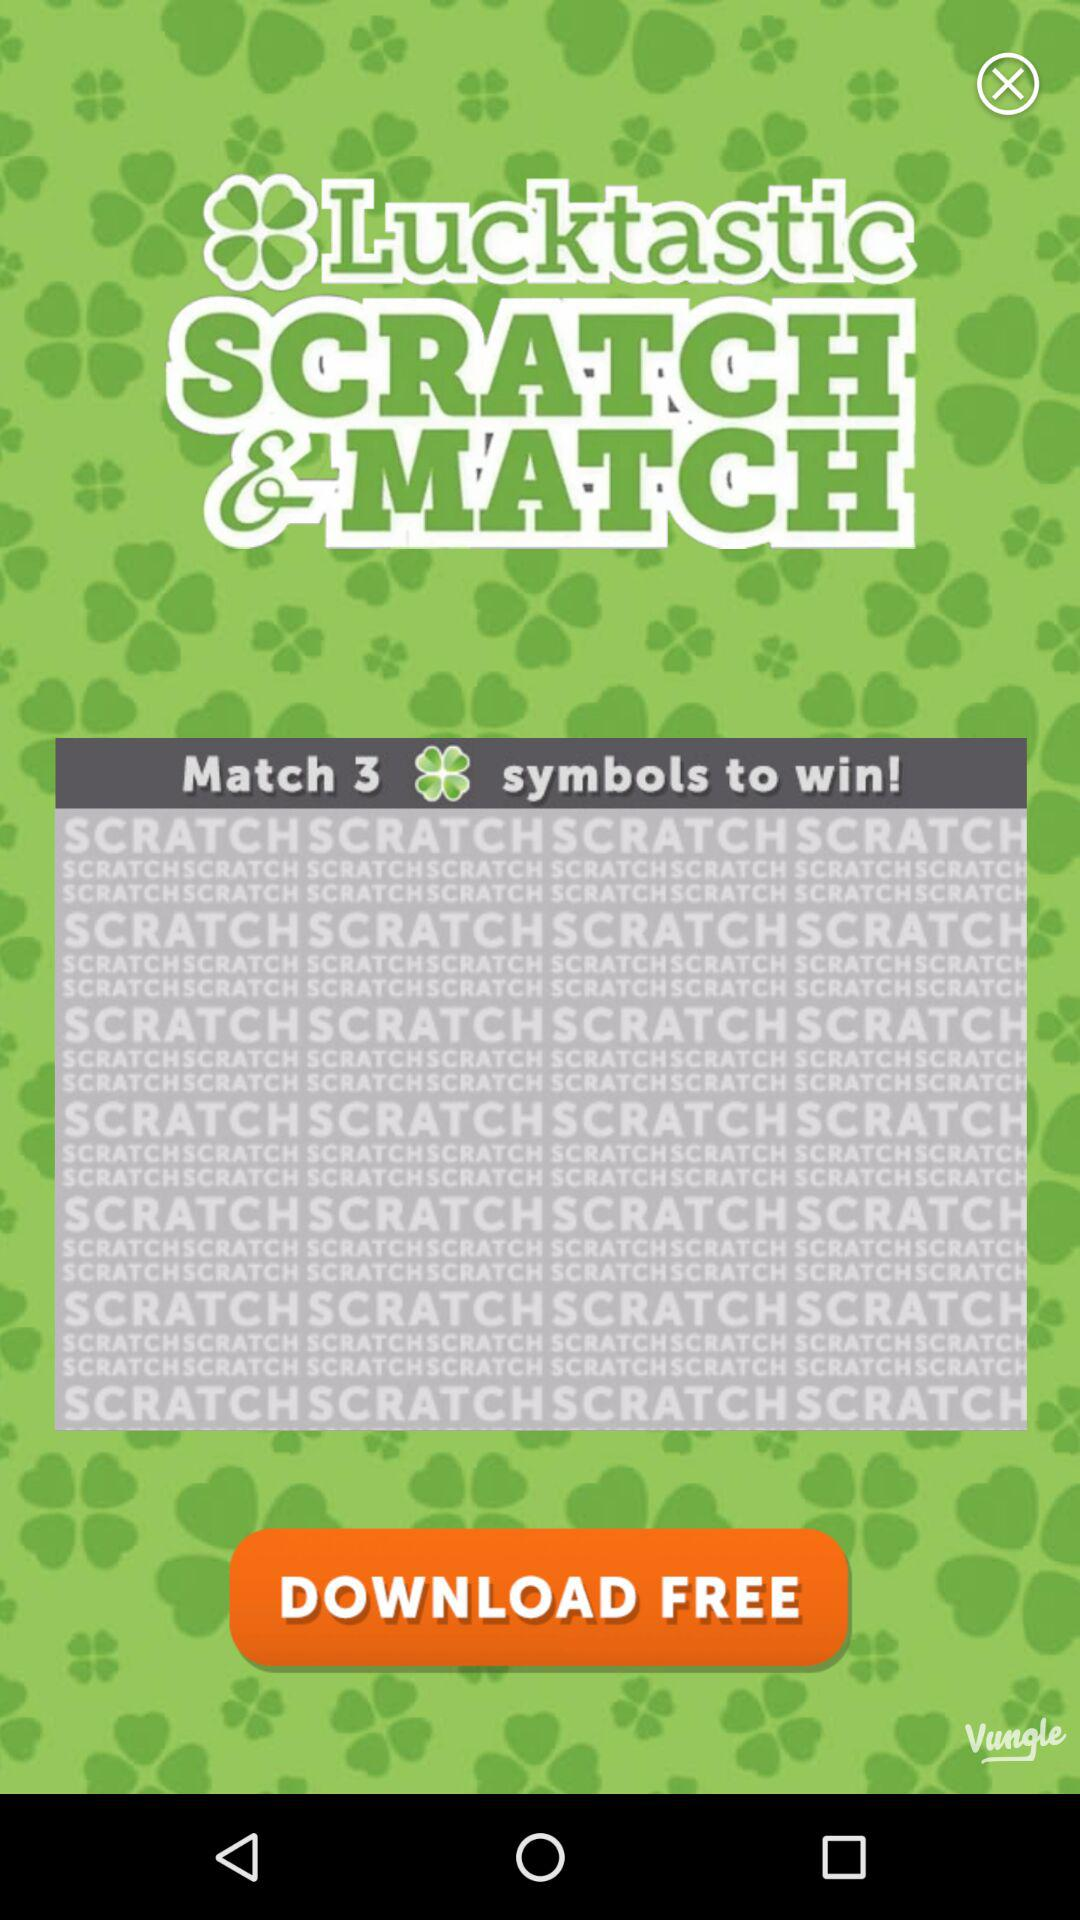What is the name of the application? The name of the application is "Lucktastic". 